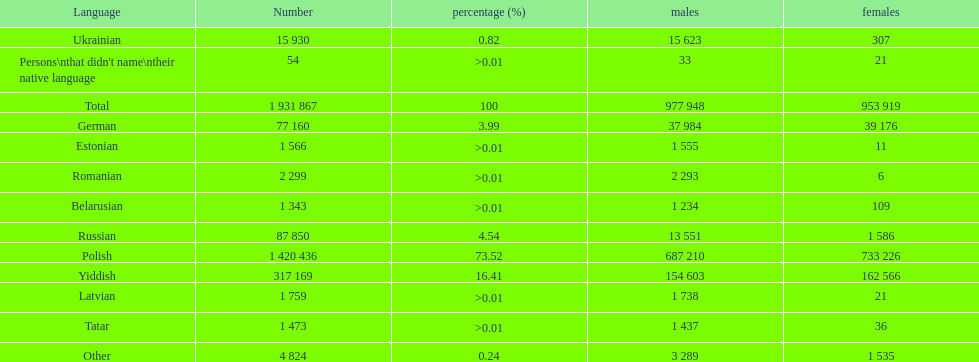The least amount of females Romanian. Can you give me this table as a dict? {'header': ['Language', 'Number', 'percentage (%)', 'males', 'females'], 'rows': [['Ukrainian', '15 930', '0.82', '15 623', '307'], ["Persons\\nthat didn't name\\ntheir native language", '54', '>0.01', '33', '21'], ['Total', '1 931 867', '100', '977 948', '953 919'], ['German', '77 160', '3.99', '37 984', '39 176'], ['Estonian', '1 566', '>0.01', '1 555', '11'], ['Romanian', '2 299', '>0.01', '2 293', '6'], ['Belarusian', '1 343', '>0.01', '1 234', '109'], ['Russian', '87 850', '4.54', '13 551', '1 586'], ['Polish', '1 420 436', '73.52', '687 210', '733 226'], ['Yiddish', '317 169', '16.41', '154 603', '162 566'], ['Latvian', '1 759', '>0.01', '1 738', '21'], ['Tatar', '1 473', '>0.01', '1 437', '36'], ['Other', '4 824', '0.24', '3 289', '1 535']]} 